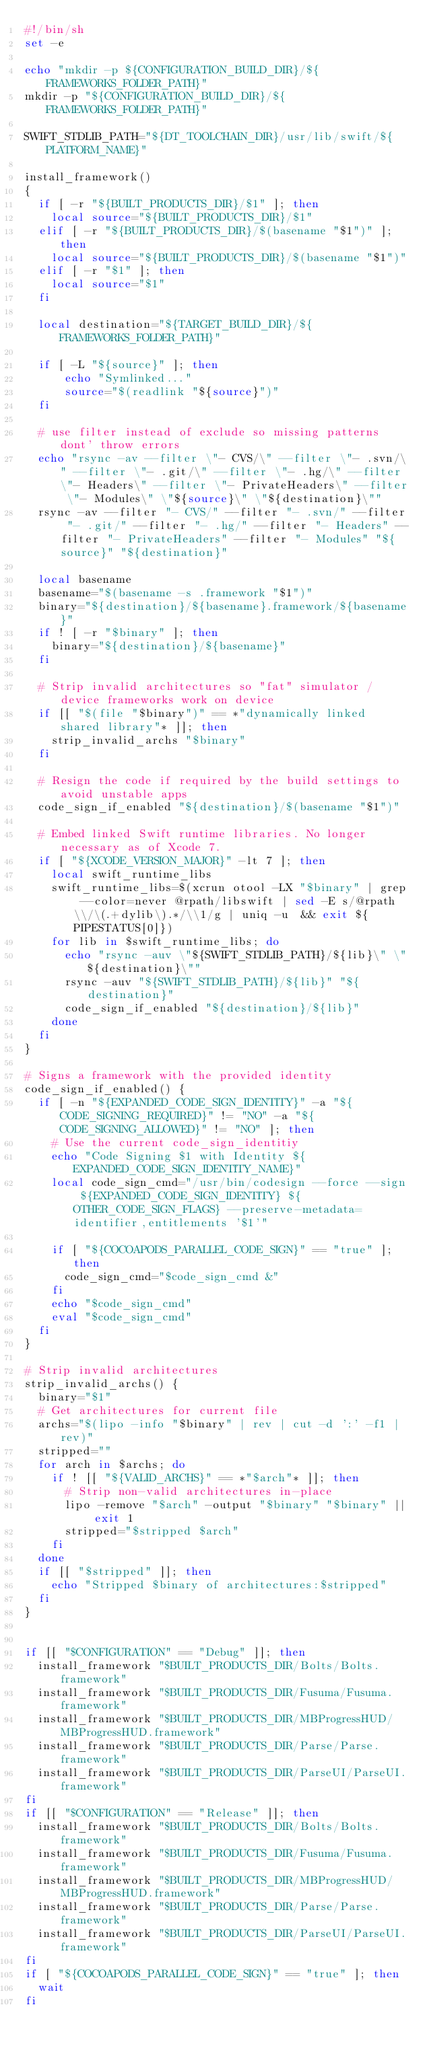Convert code to text. <code><loc_0><loc_0><loc_500><loc_500><_Bash_>#!/bin/sh
set -e

echo "mkdir -p ${CONFIGURATION_BUILD_DIR}/${FRAMEWORKS_FOLDER_PATH}"
mkdir -p "${CONFIGURATION_BUILD_DIR}/${FRAMEWORKS_FOLDER_PATH}"

SWIFT_STDLIB_PATH="${DT_TOOLCHAIN_DIR}/usr/lib/swift/${PLATFORM_NAME}"

install_framework()
{
  if [ -r "${BUILT_PRODUCTS_DIR}/$1" ]; then
    local source="${BUILT_PRODUCTS_DIR}/$1"
  elif [ -r "${BUILT_PRODUCTS_DIR}/$(basename "$1")" ]; then
    local source="${BUILT_PRODUCTS_DIR}/$(basename "$1")"
  elif [ -r "$1" ]; then
    local source="$1"
  fi

  local destination="${TARGET_BUILD_DIR}/${FRAMEWORKS_FOLDER_PATH}"

  if [ -L "${source}" ]; then
      echo "Symlinked..."
      source="$(readlink "${source}")"
  fi

  # use filter instead of exclude so missing patterns dont' throw errors
  echo "rsync -av --filter \"- CVS/\" --filter \"- .svn/\" --filter \"- .git/\" --filter \"- .hg/\" --filter \"- Headers\" --filter \"- PrivateHeaders\" --filter \"- Modules\" \"${source}\" \"${destination}\""
  rsync -av --filter "- CVS/" --filter "- .svn/" --filter "- .git/" --filter "- .hg/" --filter "- Headers" --filter "- PrivateHeaders" --filter "- Modules" "${source}" "${destination}"

  local basename
  basename="$(basename -s .framework "$1")"
  binary="${destination}/${basename}.framework/${basename}"
  if ! [ -r "$binary" ]; then
    binary="${destination}/${basename}"
  fi

  # Strip invalid architectures so "fat" simulator / device frameworks work on device
  if [[ "$(file "$binary")" == *"dynamically linked shared library"* ]]; then
    strip_invalid_archs "$binary"
  fi

  # Resign the code if required by the build settings to avoid unstable apps
  code_sign_if_enabled "${destination}/$(basename "$1")"

  # Embed linked Swift runtime libraries. No longer necessary as of Xcode 7.
  if [ "${XCODE_VERSION_MAJOR}" -lt 7 ]; then
    local swift_runtime_libs
    swift_runtime_libs=$(xcrun otool -LX "$binary" | grep --color=never @rpath/libswift | sed -E s/@rpath\\/\(.+dylib\).*/\\1/g | uniq -u  && exit ${PIPESTATUS[0]})
    for lib in $swift_runtime_libs; do
      echo "rsync -auv \"${SWIFT_STDLIB_PATH}/${lib}\" \"${destination}\""
      rsync -auv "${SWIFT_STDLIB_PATH}/${lib}" "${destination}"
      code_sign_if_enabled "${destination}/${lib}"
    done
  fi
}

# Signs a framework with the provided identity
code_sign_if_enabled() {
  if [ -n "${EXPANDED_CODE_SIGN_IDENTITY}" -a "${CODE_SIGNING_REQUIRED}" != "NO" -a "${CODE_SIGNING_ALLOWED}" != "NO" ]; then
    # Use the current code_sign_identitiy
    echo "Code Signing $1 with Identity ${EXPANDED_CODE_SIGN_IDENTITY_NAME}"
    local code_sign_cmd="/usr/bin/codesign --force --sign ${EXPANDED_CODE_SIGN_IDENTITY} ${OTHER_CODE_SIGN_FLAGS} --preserve-metadata=identifier,entitlements '$1'"

    if [ "${COCOAPODS_PARALLEL_CODE_SIGN}" == "true" ]; then
      code_sign_cmd="$code_sign_cmd &"
    fi
    echo "$code_sign_cmd"
    eval "$code_sign_cmd"
  fi
}

# Strip invalid architectures
strip_invalid_archs() {
  binary="$1"
  # Get architectures for current file
  archs="$(lipo -info "$binary" | rev | cut -d ':' -f1 | rev)"
  stripped=""
  for arch in $archs; do
    if ! [[ "${VALID_ARCHS}" == *"$arch"* ]]; then
      # Strip non-valid architectures in-place
      lipo -remove "$arch" -output "$binary" "$binary" || exit 1
      stripped="$stripped $arch"
    fi
  done
  if [[ "$stripped" ]]; then
    echo "Stripped $binary of architectures:$stripped"
  fi
}


if [[ "$CONFIGURATION" == "Debug" ]]; then
  install_framework "$BUILT_PRODUCTS_DIR/Bolts/Bolts.framework"
  install_framework "$BUILT_PRODUCTS_DIR/Fusuma/Fusuma.framework"
  install_framework "$BUILT_PRODUCTS_DIR/MBProgressHUD/MBProgressHUD.framework"
  install_framework "$BUILT_PRODUCTS_DIR/Parse/Parse.framework"
  install_framework "$BUILT_PRODUCTS_DIR/ParseUI/ParseUI.framework"
fi
if [[ "$CONFIGURATION" == "Release" ]]; then
  install_framework "$BUILT_PRODUCTS_DIR/Bolts/Bolts.framework"
  install_framework "$BUILT_PRODUCTS_DIR/Fusuma/Fusuma.framework"
  install_framework "$BUILT_PRODUCTS_DIR/MBProgressHUD/MBProgressHUD.framework"
  install_framework "$BUILT_PRODUCTS_DIR/Parse/Parse.framework"
  install_framework "$BUILT_PRODUCTS_DIR/ParseUI/ParseUI.framework"
fi
if [ "${COCOAPODS_PARALLEL_CODE_SIGN}" == "true" ]; then
  wait
fi
</code> 